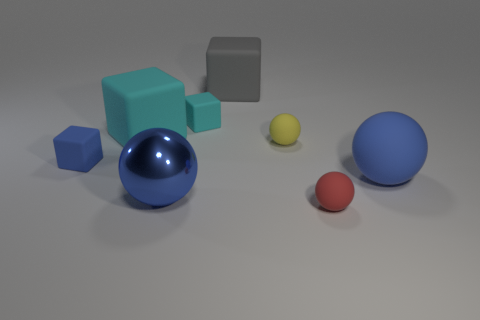Are there any other things that have the same material as the large gray cube?
Ensure brevity in your answer.  Yes. What material is the other large ball that is the same color as the large rubber ball?
Your response must be concise. Metal. Are there any rubber spheres of the same color as the metallic ball?
Make the answer very short. Yes. There is a blue sphere that is on the right side of the small ball that is in front of the large metal sphere; is there a big blue sphere that is in front of it?
Your response must be concise. Yes. What number of other things are there of the same shape as the small cyan thing?
Keep it short and to the point. 3. There is a small sphere in front of the big blue object to the left of the tiny object behind the large cyan block; what is its color?
Give a very brief answer. Red. How many large matte things are there?
Your answer should be compact. 3. What number of small objects are yellow objects or red objects?
Make the answer very short. 2. There is a blue matte thing that is the same size as the red ball; what is its shape?
Your response must be concise. Cube. There is a big blue sphere right of the tiny object that is in front of the tiny blue cube; what is it made of?
Keep it short and to the point. Rubber. 